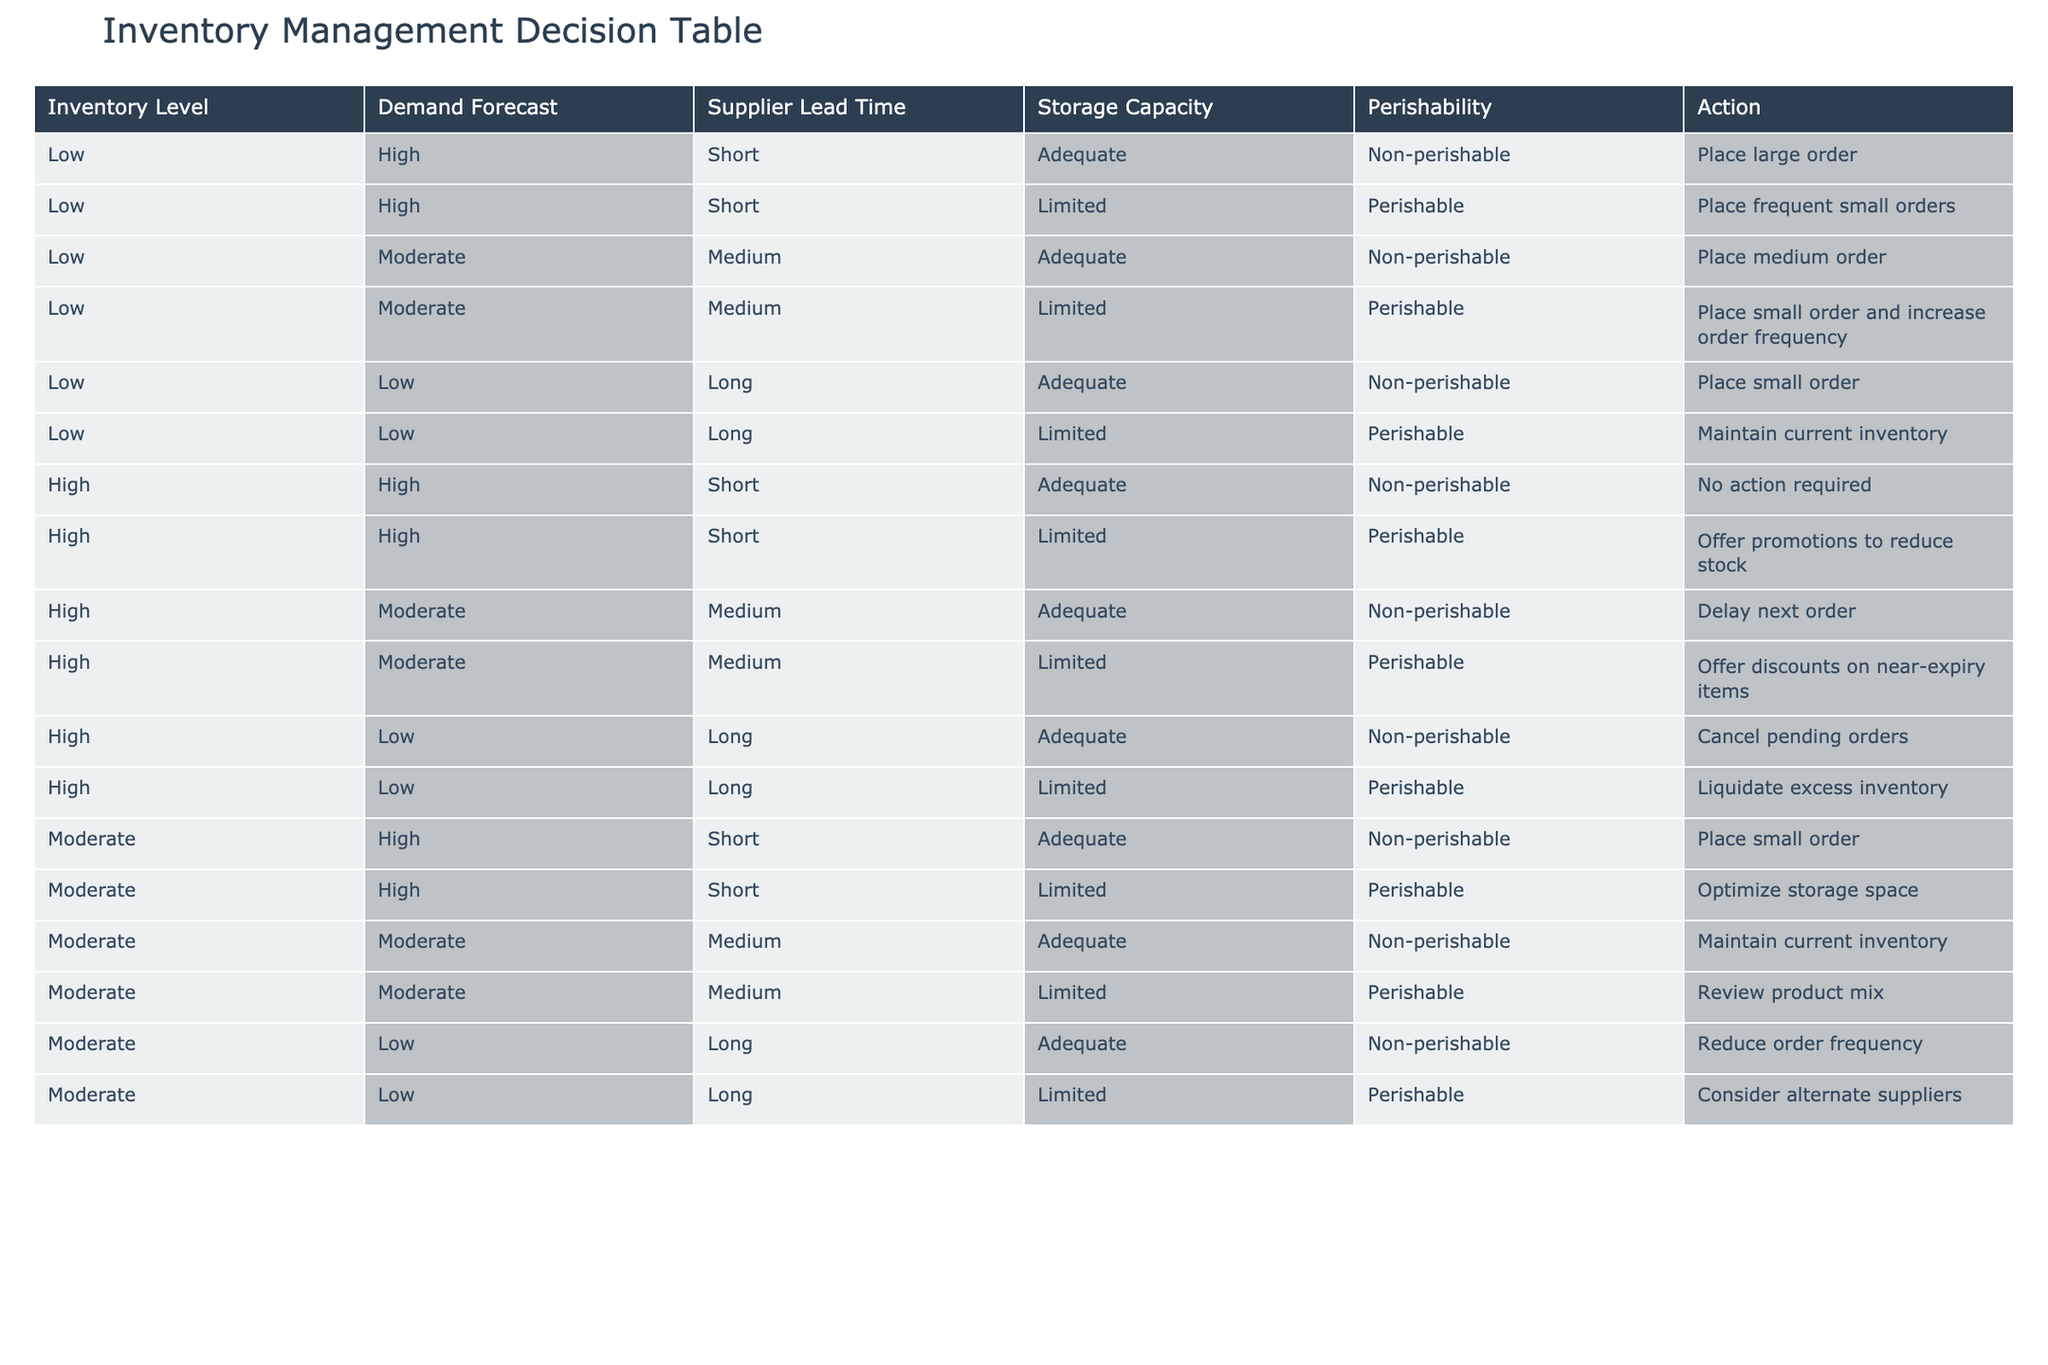What action should be taken if the inventory level is low, demand forecast is high, and supplier lead time is short for a non-perishable item? According to the table, if the inventory level is low, demand forecast is high, and supplier lead time is short for a non-perishable item, the recommended action is to place a large order.
Answer: Place large order What action is advised when the inventory level is high, demand forecast is moderate, and storage capacity is limited for a perishable item? In this case, the table indicates that the appropriate action would be to offer discounts on near-expiry items to manage the inventory effectively.
Answer: Offer discounts on near-expiry items Is it advisable to maintain current inventory levels if the inventory level is low, demand forecast is low, and supplier lead time is long for a non-perishable item? No, the table suggests placing a small order instead, not maintaining the current inventory.
Answer: No What action should a company take when dealing with moderate inventory levels, high demand, and limited storage space for a perishable item? The table specifies that the action in this scenario should be to optimize storage space, allowing for better management of perishable goods.
Answer: Optimize storage space If the demand forecast is moderate and the inventory level is high with adequate storage capacity, what should the company do? According to the table, the recommendation in this situation is to maintain current inventory levels, ensuring that there is no unnecessary action required.
Answer: Maintain current inventory What is the total number of actions recommended for low inventory levels regardless of demand forecast and perishability? By filtering the table for low inventory levels, we find 5 different actions recommended. These are: place large order, place frequent small orders, place medium order, place small order and increase order frequency, and maintain current inventory. Summing these, we find a total of 5 actions.
Answer: 5 If the supplier lead time is long, what actions are recommended for perishable items when the inventory level is low and demand is low? The table indicates that the recommended action is to maintain current inventory for low demand and low inventory levels, specifically for perishable items.
Answer: Maintain current inventory What is the common action advised for high inventory levels with a high demand forecast regardless of the perishability of items? When the inventory is high and demand forecast is high, for non-perishable items, the table specifies that no action is required. However, for perishable items, it suggests offering promotions to reduce stock. Hence, there's a distinction based on perishability leading to different actions.
Answer: No action required / Offer promotions What action should be taken if the inventory level is moderate with low demand and a long supplier lead time for perishable goods? The table indicates that the appropriate action would be to consider alternate suppliers in order to mitigate the impact of low demand and slow delivery times for perishable items.
Answer: Consider alternate suppliers 